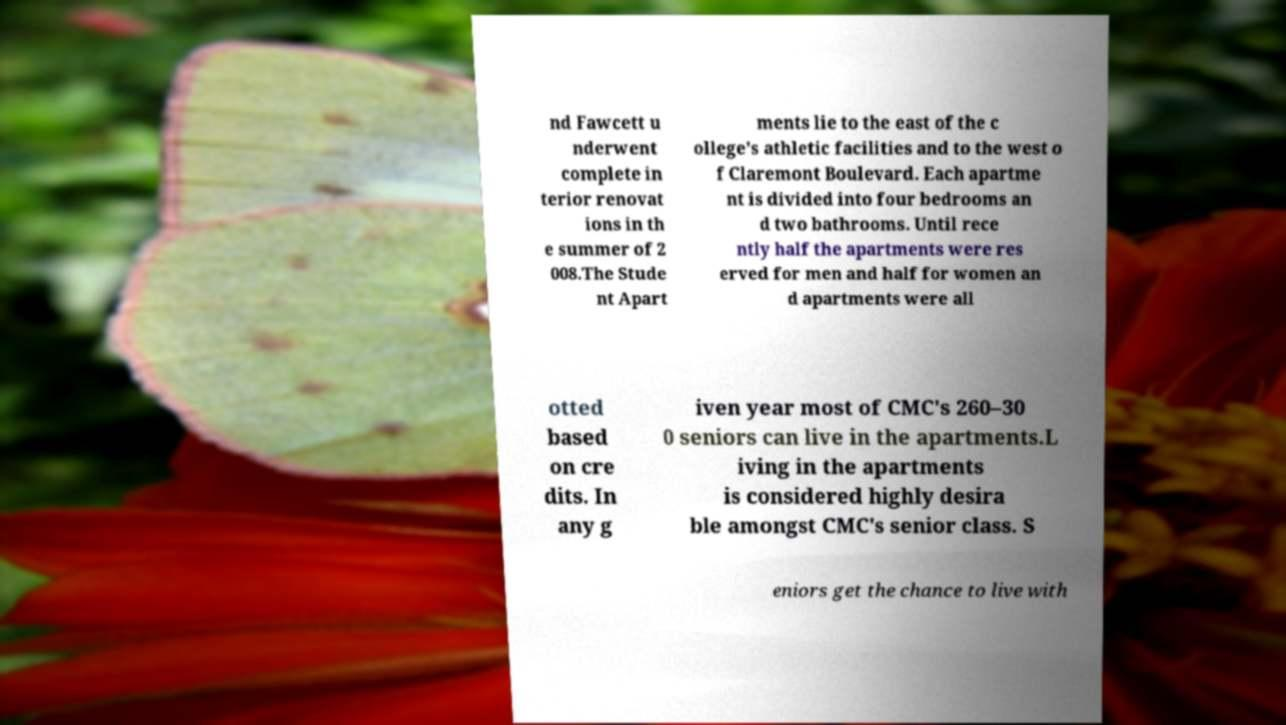Could you extract and type out the text from this image? nd Fawcett u nderwent complete in terior renovat ions in th e summer of 2 008.The Stude nt Apart ments lie to the east of the c ollege's athletic facilities and to the west o f Claremont Boulevard. Each apartme nt is divided into four bedrooms an d two bathrooms. Until rece ntly half the apartments were res erved for men and half for women an d apartments were all otted based on cre dits. In any g iven year most of CMC's 260–30 0 seniors can live in the apartments.L iving in the apartments is considered highly desira ble amongst CMC's senior class. S eniors get the chance to live with 